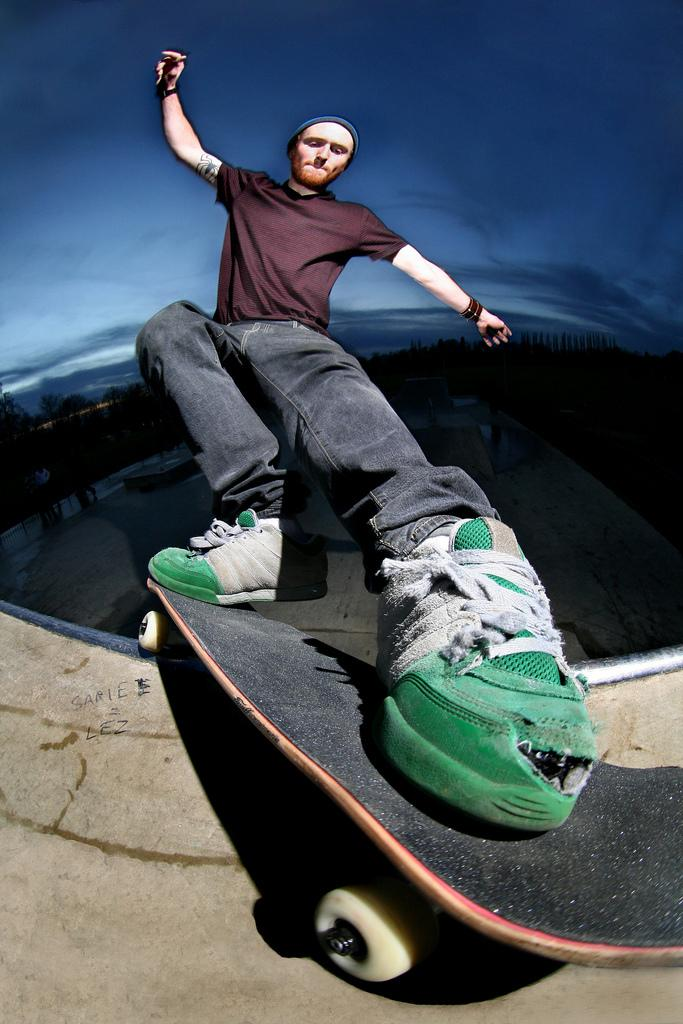Who is the main subject in the image? There is a man in the image. What is the man doing in the image? The man is on a skateboard. What can be seen in the background of the image? The background of the image is dark. What part of the natural environment is visible in the image? The sky is visible in the image. What type of ink can be seen on the farmer's shirt in the image? There is no farmer or ink present in the image; it features a man on a skateboard with a dark background and visible sky. 